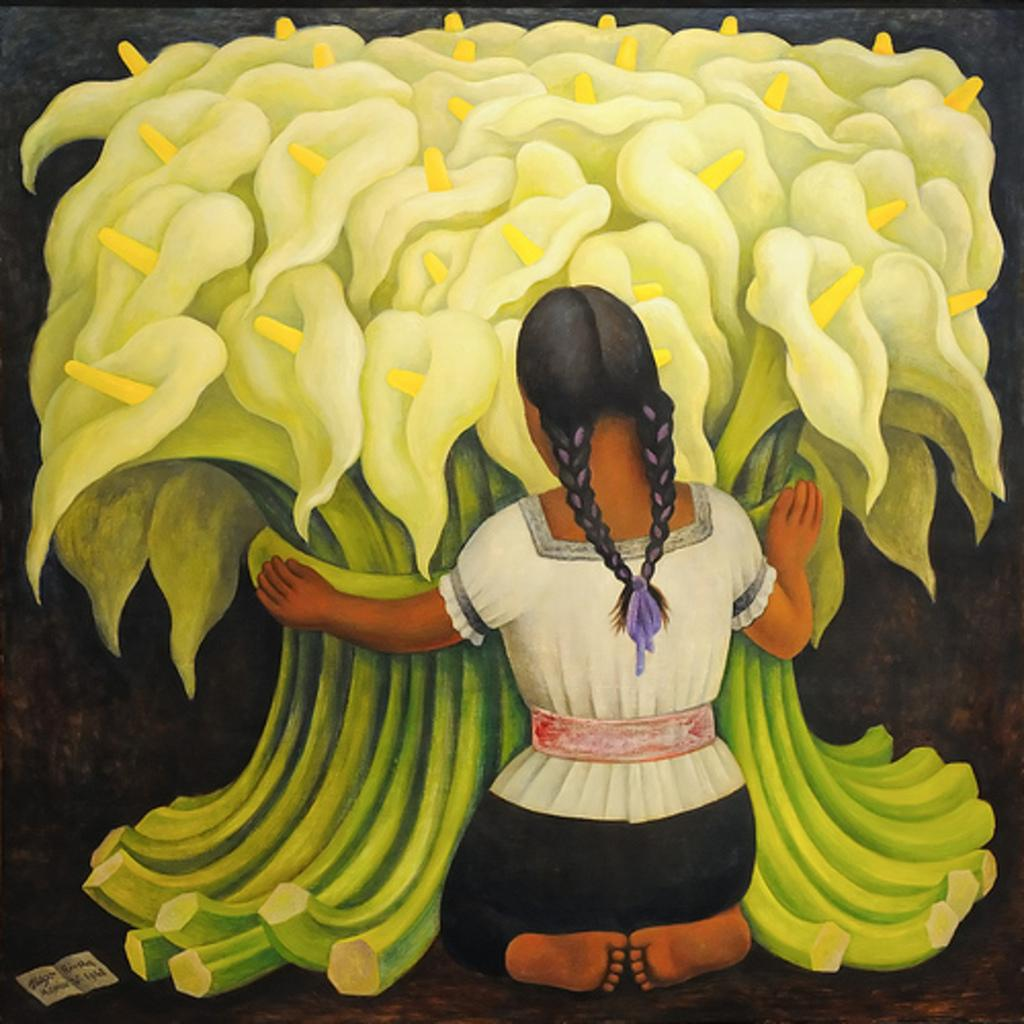What is the main subject of the painting in the image? The painting depicts a girl. Are there any other elements in the painting besides the girl? Yes, the painting also includes flowers. What type of plant is growing in the girl's hair in the image? There is no plant growing in the girl's hair in the image; the painting only depicts a girl and flowers. 